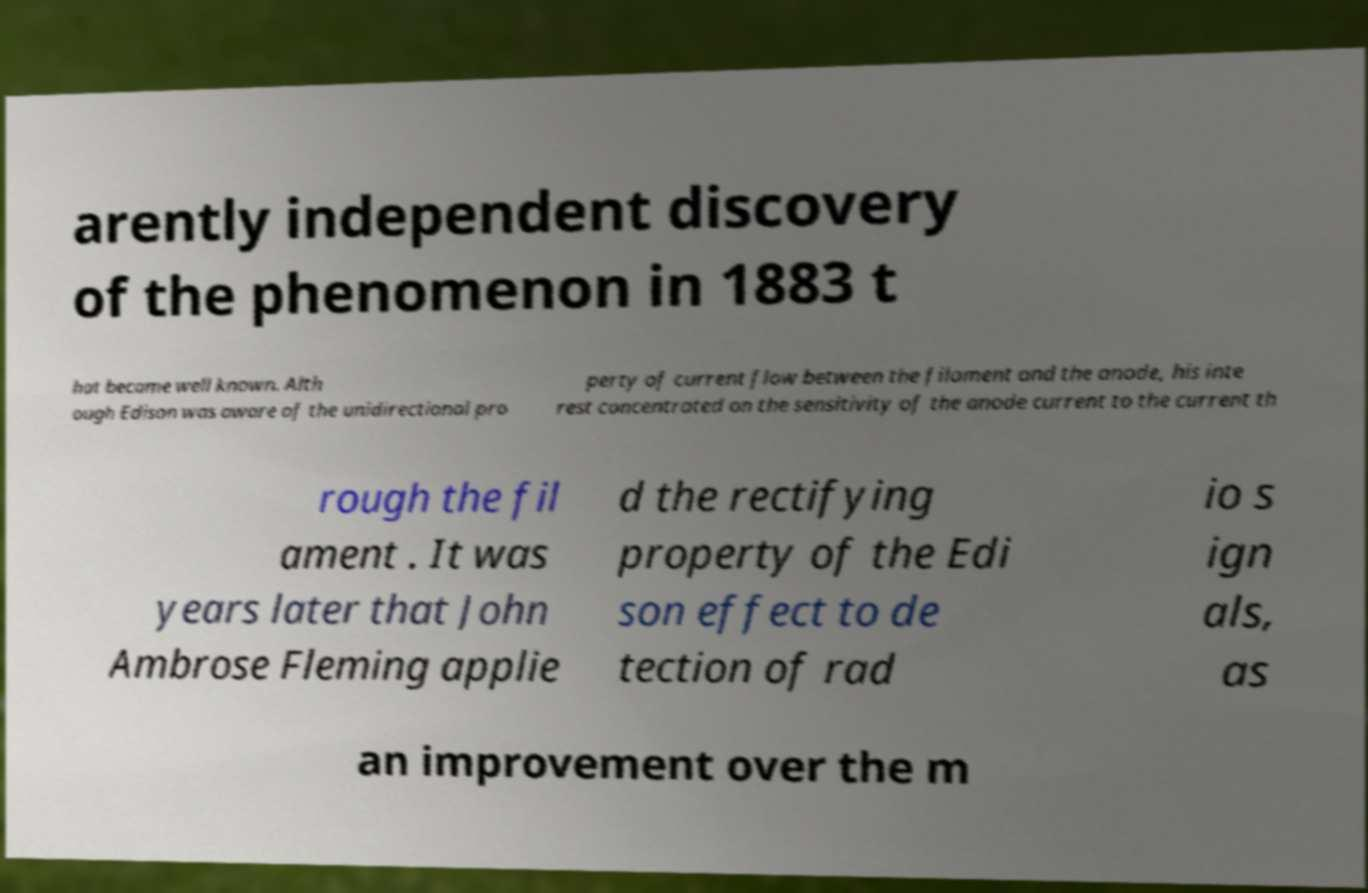For documentation purposes, I need the text within this image transcribed. Could you provide that? arently independent discovery of the phenomenon in 1883 t hat became well known. Alth ough Edison was aware of the unidirectional pro perty of current flow between the filament and the anode, his inte rest concentrated on the sensitivity of the anode current to the current th rough the fil ament . It was years later that John Ambrose Fleming applie d the rectifying property of the Edi son effect to de tection of rad io s ign als, as an improvement over the m 